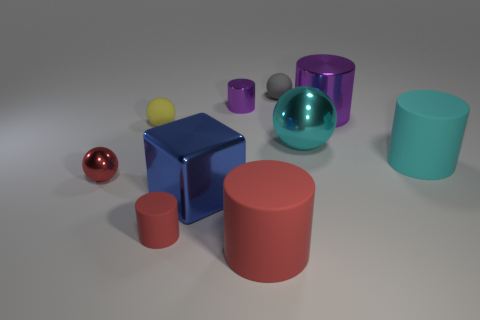What materials appear to be represented in this collection of objects? The objects in this image seem to represent various materials including matte surfaces on the cyan and red cylinders, a reflective metallic surface on the blue cube and the sphere to the left, and a semi-transparent glossy surface on the large teal sphere. 